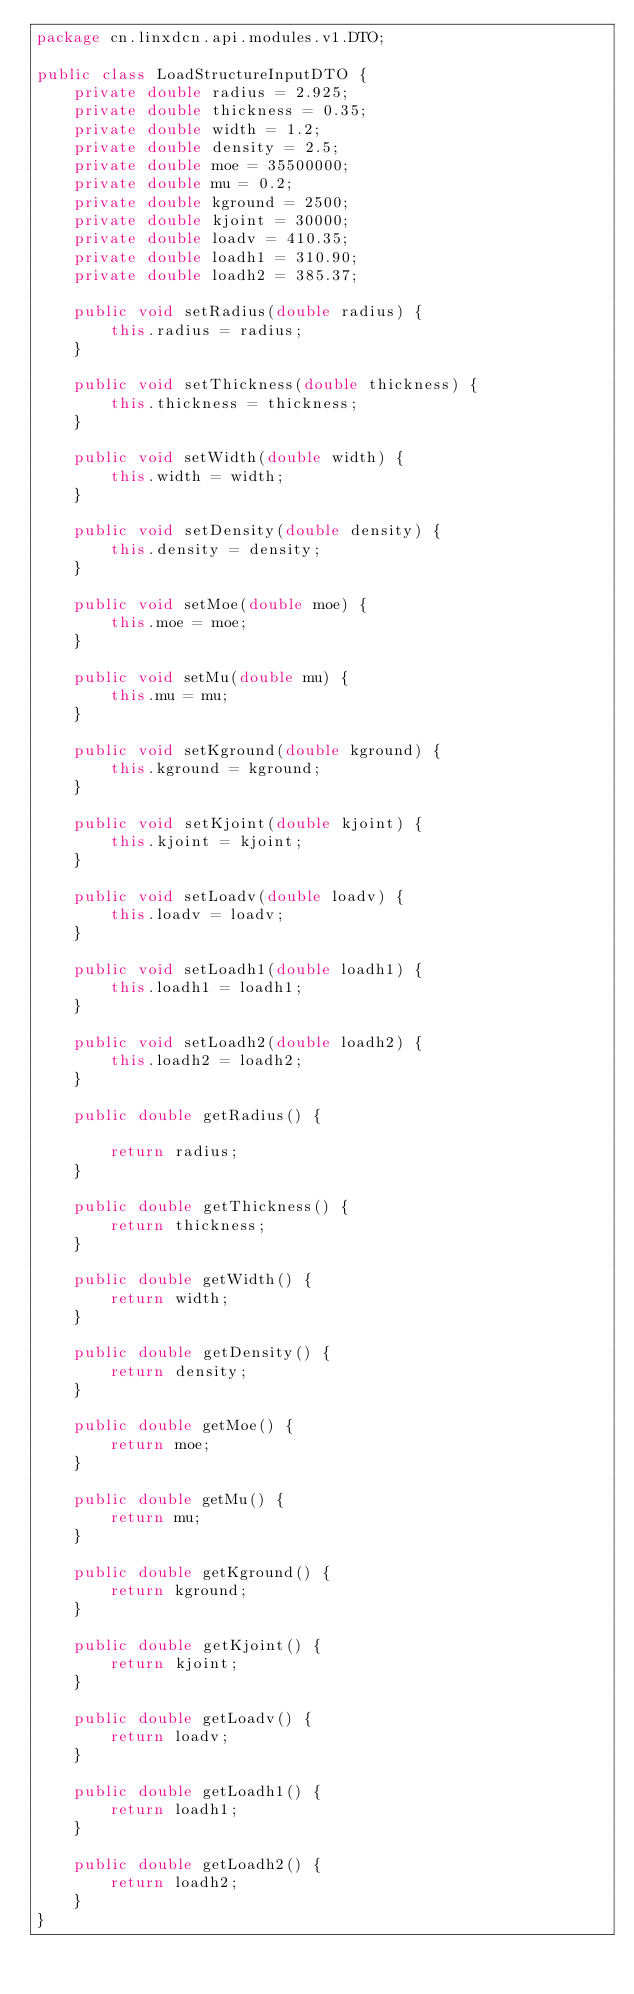Convert code to text. <code><loc_0><loc_0><loc_500><loc_500><_Java_>package cn.linxdcn.api.modules.v1.DTO;

public class LoadStructureInputDTO {
    private double radius = 2.925;
    private double thickness = 0.35;
    private double width = 1.2;
    private double density = 2.5;
    private double moe = 35500000;
    private double mu = 0.2;
    private double kground = 2500;
    private double kjoint = 30000;
    private double loadv = 410.35;
    private double loadh1 = 310.90;
    private double loadh2 = 385.37;

    public void setRadius(double radius) {
        this.radius = radius;
    }

    public void setThickness(double thickness) {
        this.thickness = thickness;
    }

    public void setWidth(double width) {
        this.width = width;
    }

    public void setDensity(double density) {
        this.density = density;
    }

    public void setMoe(double moe) {
        this.moe = moe;
    }

    public void setMu(double mu) {
        this.mu = mu;
    }

    public void setKground(double kground) {
        this.kground = kground;
    }

    public void setKjoint(double kjoint) {
        this.kjoint = kjoint;
    }

    public void setLoadv(double loadv) {
        this.loadv = loadv;
    }

    public void setLoadh1(double loadh1) {
        this.loadh1 = loadh1;
    }

    public void setLoadh2(double loadh2) {
        this.loadh2 = loadh2;
    }

    public double getRadius() {

        return radius;
    }

    public double getThickness() {
        return thickness;
    }

    public double getWidth() {
        return width;
    }

    public double getDensity() {
        return density;
    }

    public double getMoe() {
        return moe;
    }

    public double getMu() {
        return mu;
    }

    public double getKground() {
        return kground;
    }

    public double getKjoint() {
        return kjoint;
    }

    public double getLoadv() {
        return loadv;
    }

    public double getLoadh1() {
        return loadh1;
    }

    public double getLoadh2() {
        return loadh2;
    }
}
</code> 